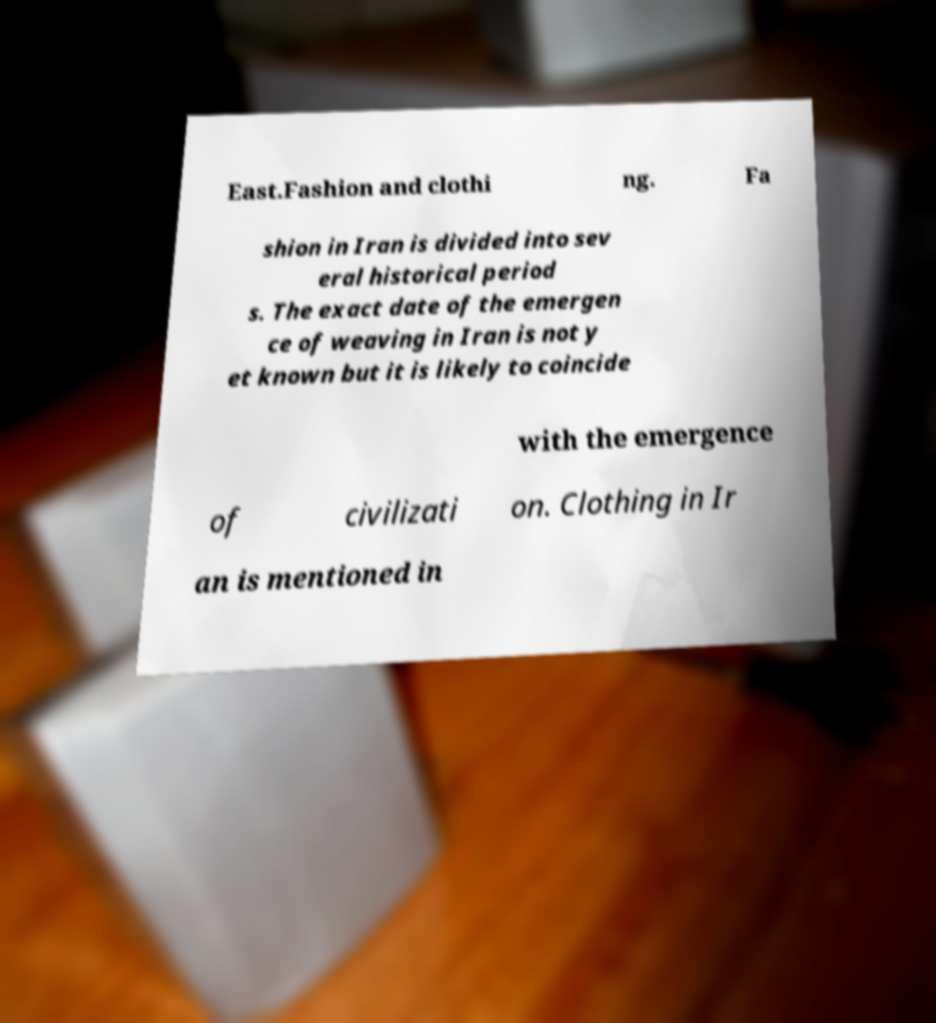For documentation purposes, I need the text within this image transcribed. Could you provide that? East.Fashion and clothi ng. Fa shion in Iran is divided into sev eral historical period s. The exact date of the emergen ce of weaving in Iran is not y et known but it is likely to coincide with the emergence of civilizati on. Clothing in Ir an is mentioned in 